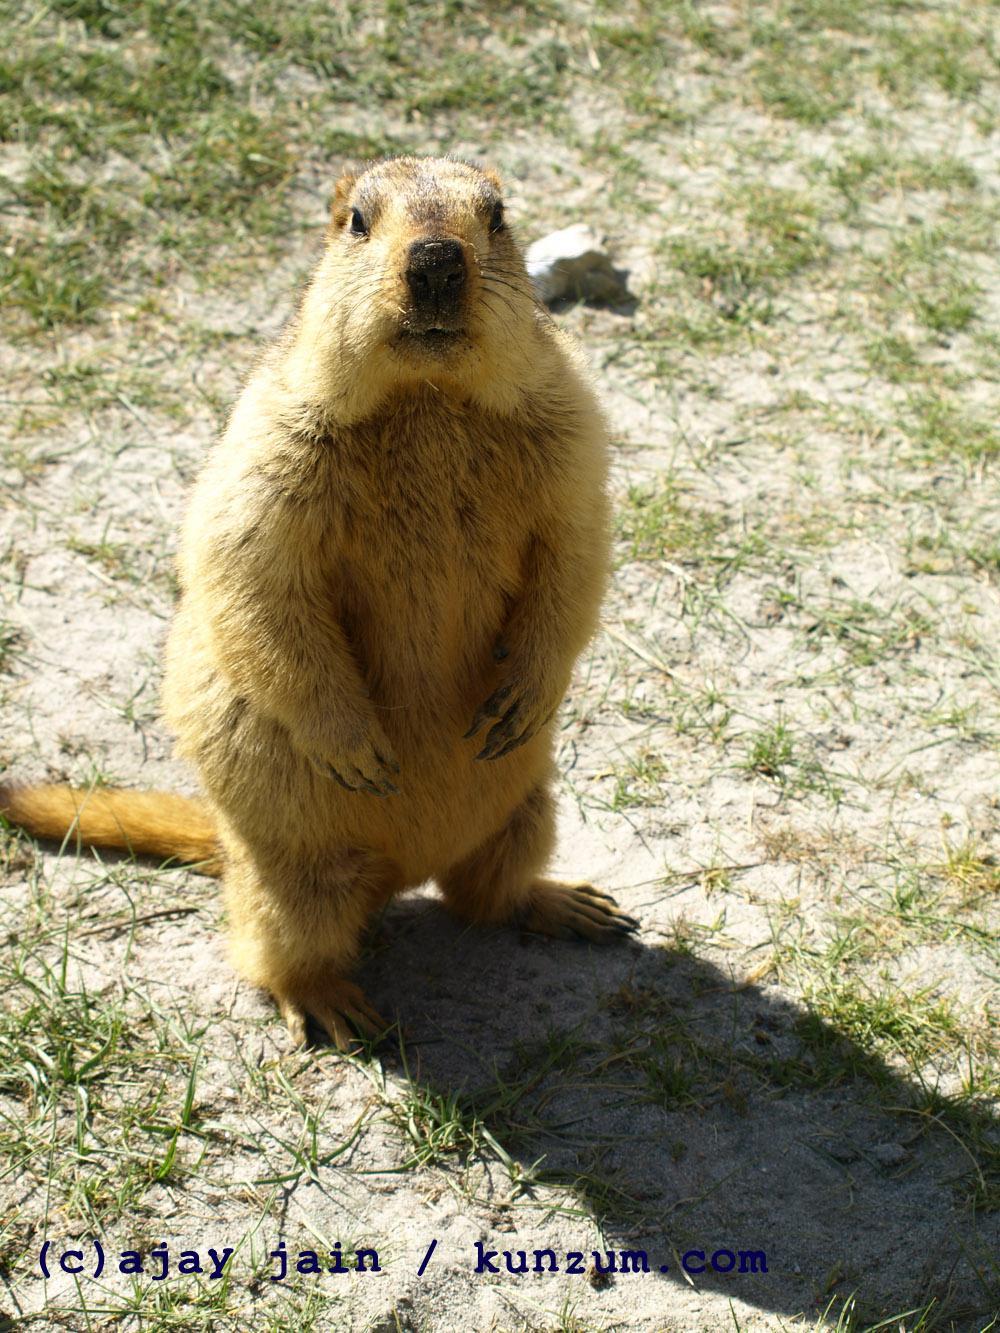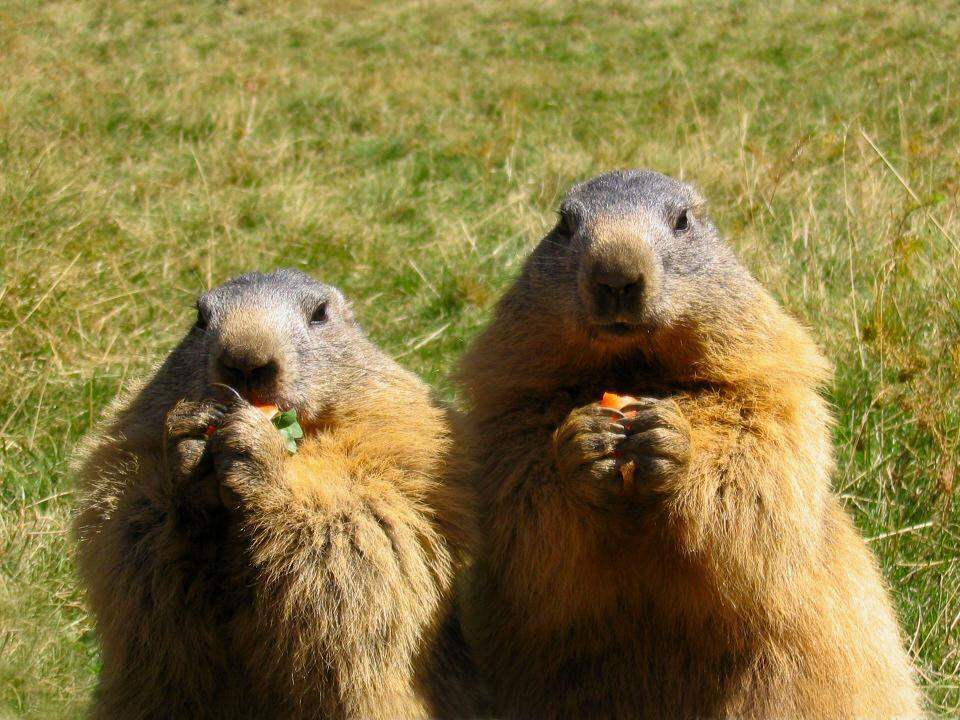The first image is the image on the left, the second image is the image on the right. For the images displayed, is the sentence "There is a total of three animals in the pair of images." factually correct? Answer yes or no. Yes. 